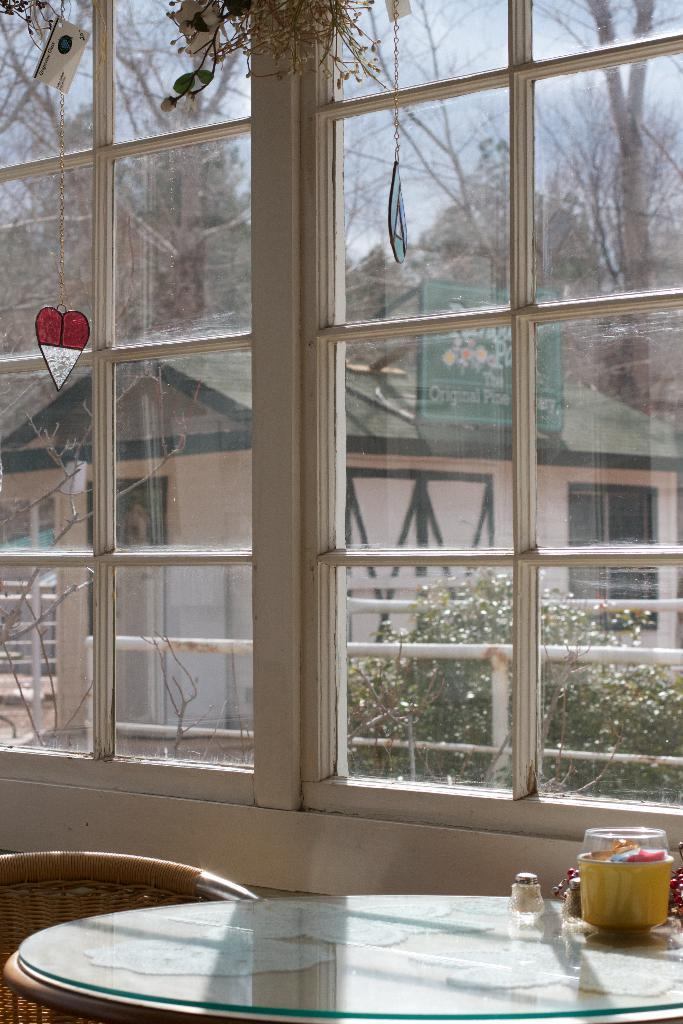What type of furniture is present in the image? There is a table and a chair in the image. What items can be seen on the table? There are bottles, a box, and glasses on the table. What can be seen through the glass in the image? Plants, trees, a house, a board, and the sky are visible through the glass. What type of string is being used to tie the nut to the board in the image? There is no string or nut present in the image. 